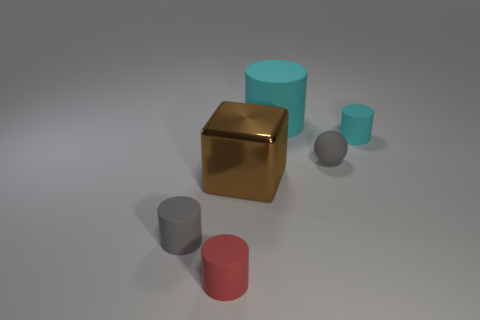There is a tiny object that is the same color as the small matte ball; what is its material?
Offer a very short reply. Rubber. Does the large rubber thing have the same color as the small rubber cylinder that is right of the big cube?
Provide a short and direct response. Yes. Is the color of the rubber cylinder that is left of the red matte thing the same as the ball?
Keep it short and to the point. Yes. How many large things are yellow rubber objects or matte cylinders?
Make the answer very short. 1. Is the number of tiny cyan rubber cylinders greater than the number of tiny yellow blocks?
Provide a succinct answer. Yes. Is the material of the tiny sphere the same as the red object?
Provide a short and direct response. Yes. Is there any other thing that is made of the same material as the big block?
Your answer should be very brief. No. Is the number of tiny gray rubber balls behind the red matte cylinder greater than the number of green metallic cylinders?
Keep it short and to the point. Yes. What number of other big rubber objects are the same shape as the large cyan thing?
Provide a short and direct response. 0. There is a cyan object that is the same material as the small cyan cylinder; what is its size?
Your response must be concise. Large. 